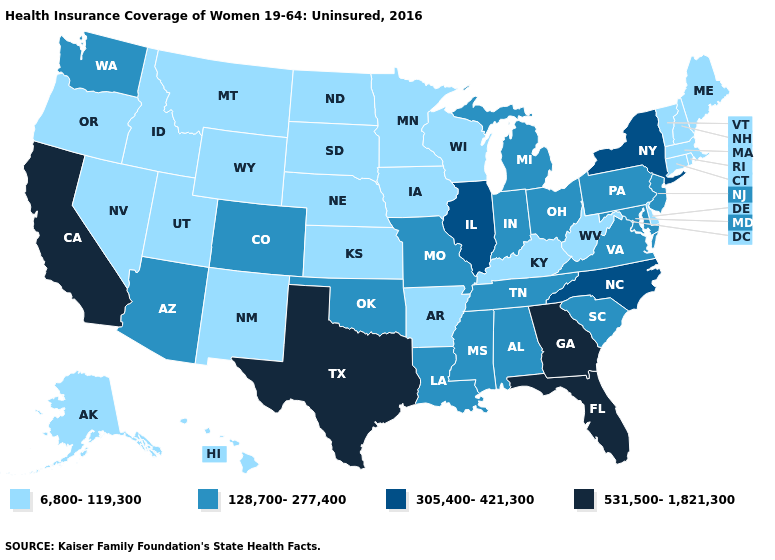Among the states that border Connecticut , which have the lowest value?
Concise answer only. Massachusetts, Rhode Island. Name the states that have a value in the range 128,700-277,400?
Short answer required. Alabama, Arizona, Colorado, Indiana, Louisiana, Maryland, Michigan, Mississippi, Missouri, New Jersey, Ohio, Oklahoma, Pennsylvania, South Carolina, Tennessee, Virginia, Washington. Which states have the lowest value in the MidWest?
Short answer required. Iowa, Kansas, Minnesota, Nebraska, North Dakota, South Dakota, Wisconsin. Which states hav the highest value in the South?
Concise answer only. Florida, Georgia, Texas. Which states have the lowest value in the MidWest?
Concise answer only. Iowa, Kansas, Minnesota, Nebraska, North Dakota, South Dakota, Wisconsin. Does the map have missing data?
Answer briefly. No. Among the states that border Louisiana , does Arkansas have the lowest value?
Short answer required. Yes. What is the lowest value in states that border Texas?
Concise answer only. 6,800-119,300. Does California have the highest value in the West?
Keep it brief. Yes. Which states hav the highest value in the MidWest?
Give a very brief answer. Illinois. Does Iowa have the highest value in the USA?
Quick response, please. No. What is the lowest value in states that border California?
Answer briefly. 6,800-119,300. What is the value of Mississippi?
Quick response, please. 128,700-277,400. What is the value of Maine?
Write a very short answer. 6,800-119,300. 